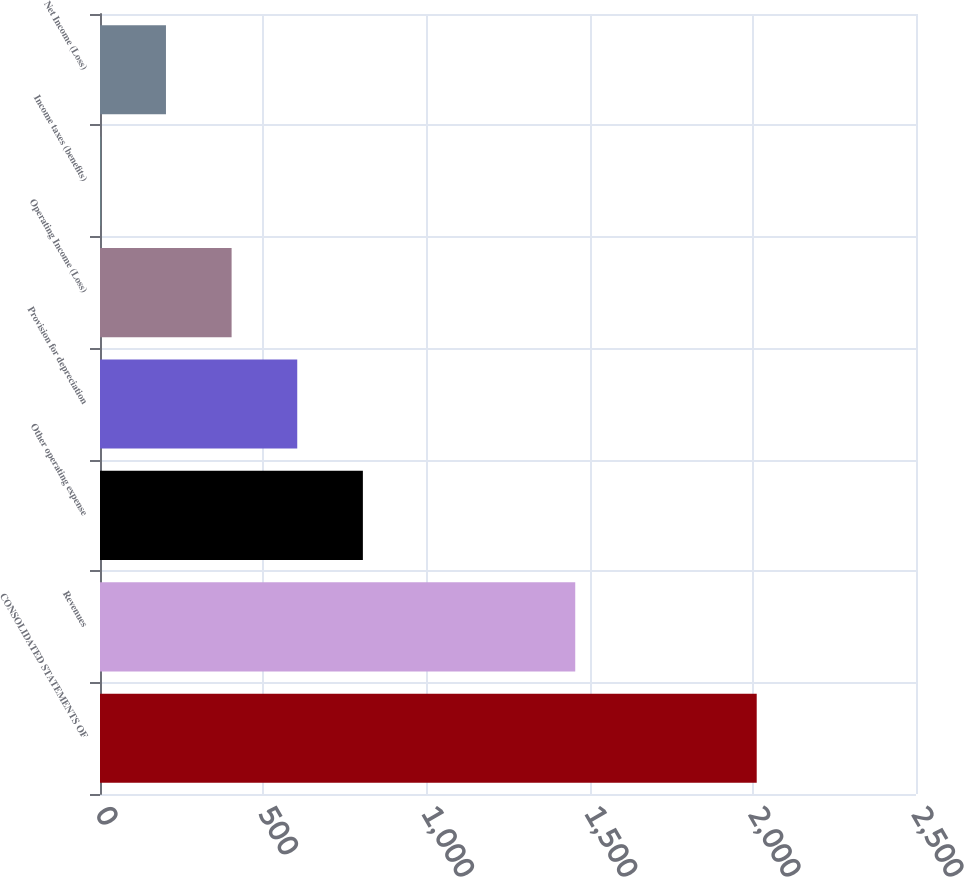Convert chart to OTSL. <chart><loc_0><loc_0><loc_500><loc_500><bar_chart><fcel>CONSOLIDATED STATEMENTS OF<fcel>Revenues<fcel>Other operating expense<fcel>Provision for depreciation<fcel>Operating Income (Loss)<fcel>Income taxes (benefits)<fcel>Net Income (Loss)<nl><fcel>2012<fcel>1456<fcel>805.4<fcel>604.3<fcel>403.2<fcel>1<fcel>202.1<nl></chart> 